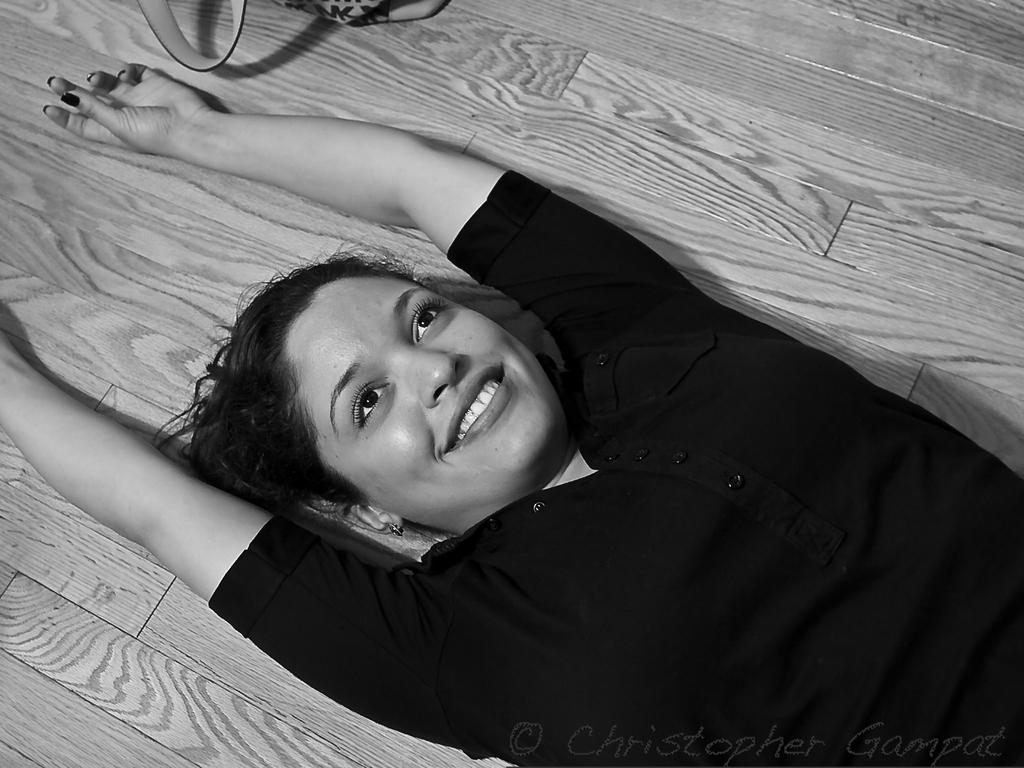Who is the main subject in the image? There is a lady in the image. What is the lady doing in the image? The lady is lying down on the floor. What color is the dress the lady is wearing? The lady is wearing a black color dress. What type of mask is the lady wearing in the image? There is no mask visible on the lady in the image. 